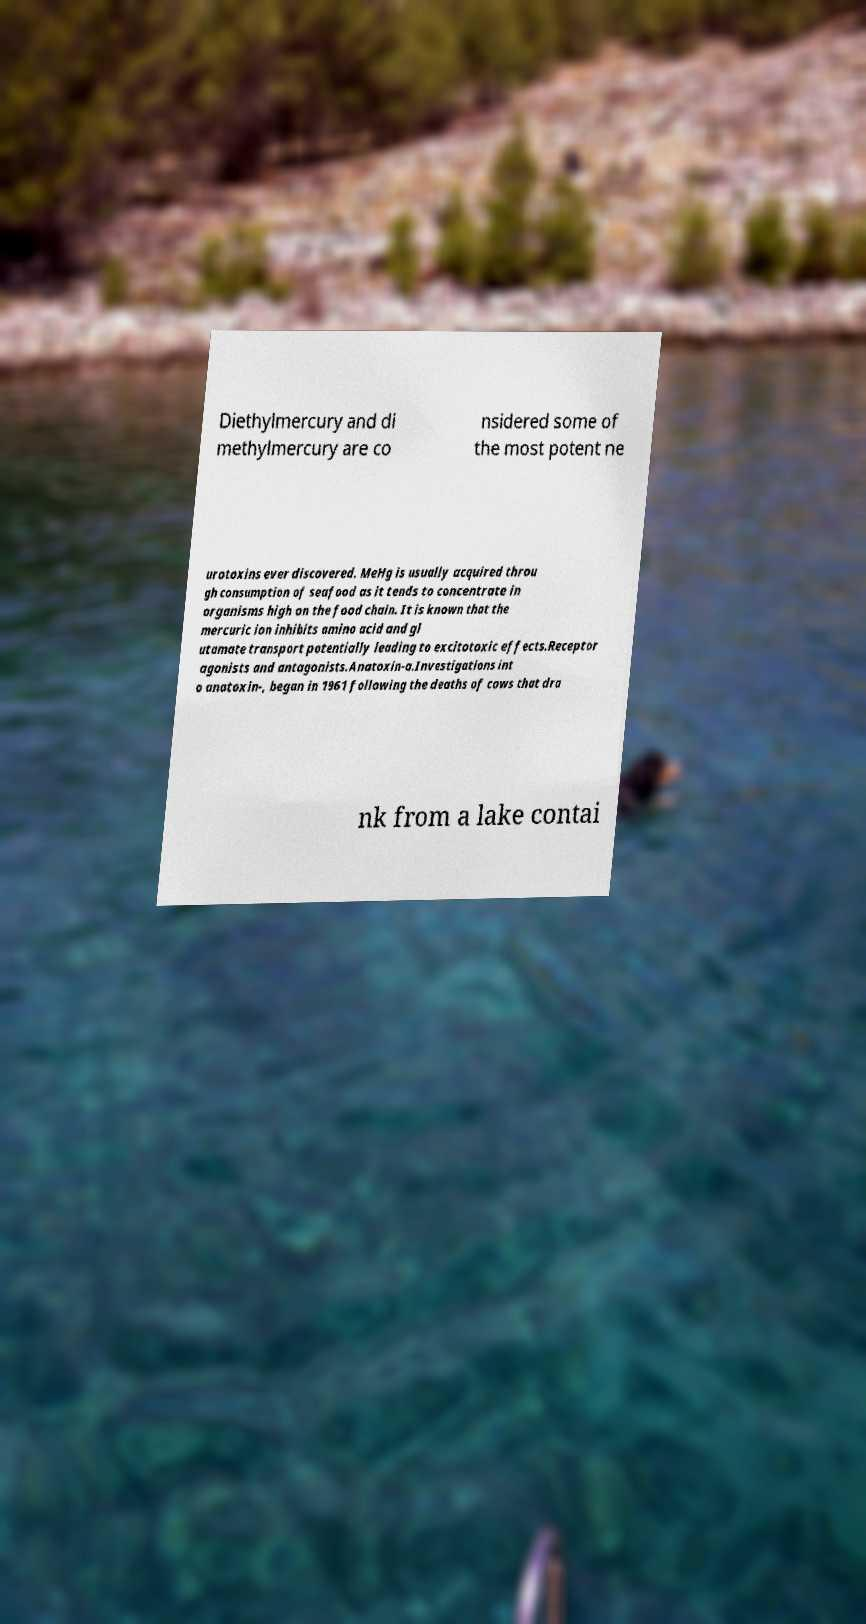I need the written content from this picture converted into text. Can you do that? Diethylmercury and di methylmercury are co nsidered some of the most potent ne urotoxins ever discovered. MeHg is usually acquired throu gh consumption of seafood as it tends to concentrate in organisms high on the food chain. It is known that the mercuric ion inhibits amino acid and gl utamate transport potentially leading to excitotoxic effects.Receptor agonists and antagonists.Anatoxin-a.Investigations int o anatoxin-, began in 1961 following the deaths of cows that dra nk from a lake contai 